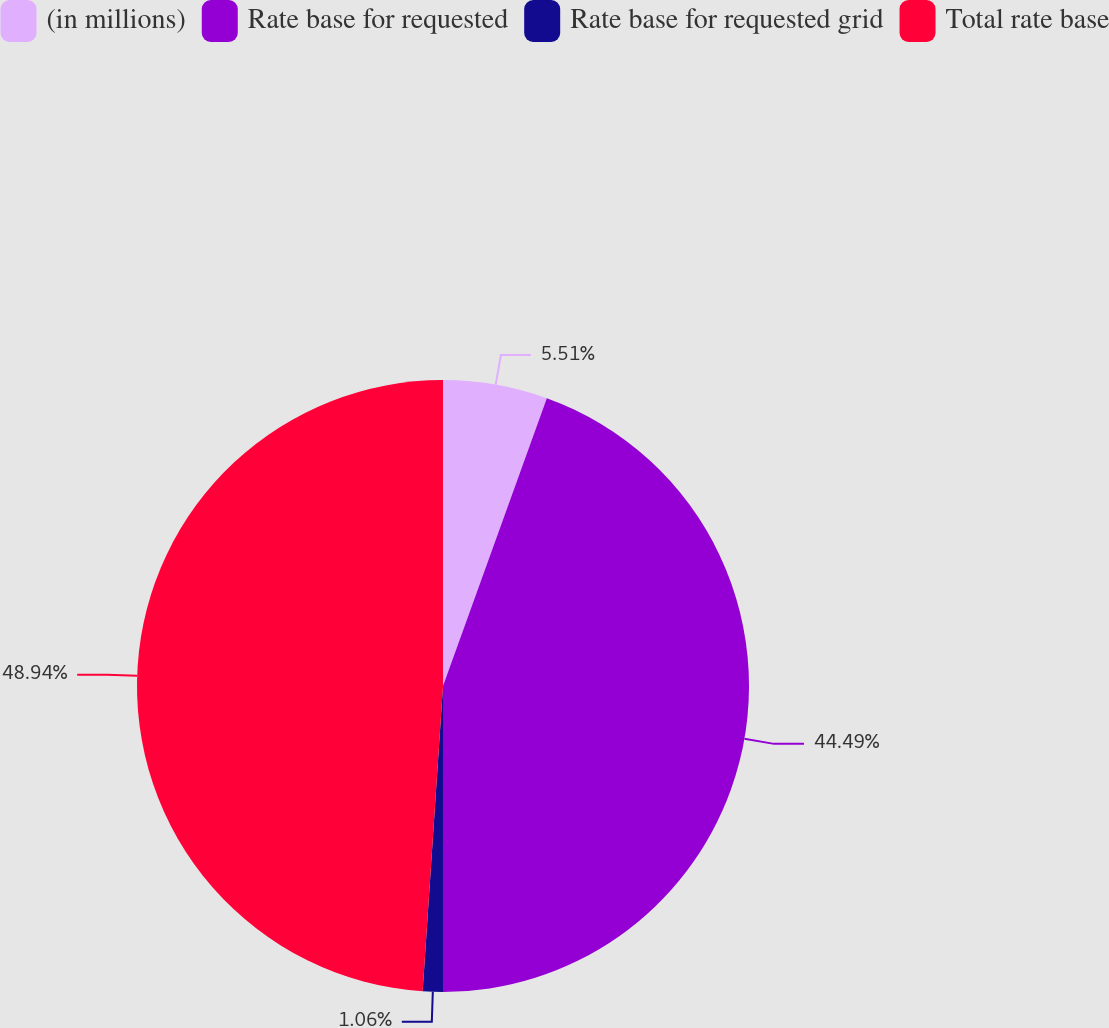<chart> <loc_0><loc_0><loc_500><loc_500><pie_chart><fcel>(in millions)<fcel>Rate base for requested<fcel>Rate base for requested grid<fcel>Total rate base<nl><fcel>5.51%<fcel>44.49%<fcel>1.06%<fcel>48.94%<nl></chart> 